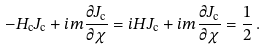<formula> <loc_0><loc_0><loc_500><loc_500>- H _ { \mathrm c } J _ { \mathrm c } + i m \frac { \partial J _ { \mathrm c } } { \partial \chi } = i H J _ { \mathrm c } + i m \frac { \partial J _ { \mathrm c } } { \partial \chi } = \frac { 1 } { 2 } \, .</formula> 